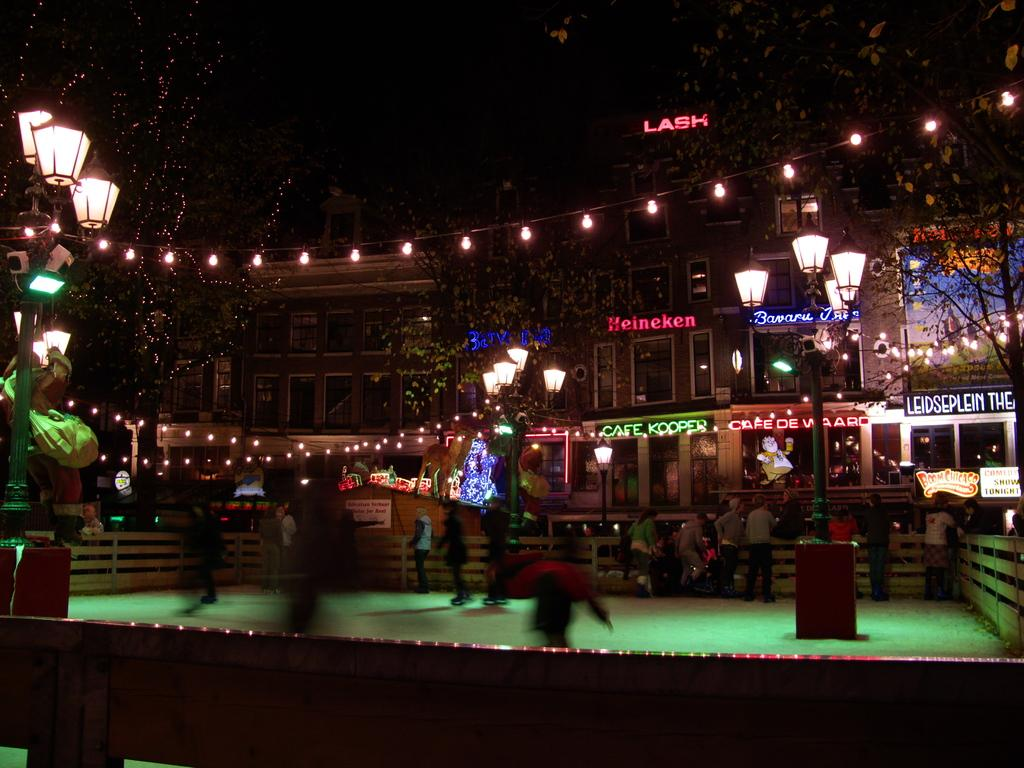What can be seen on the path in the image? There are people on the path in the image. What is present from left to right in the image? There is fencing from left to right in the image. What can be seen in the background of the image? There are lights and buildings visible in the background of the image. What type of thought can be seen in the image? There is no thought visible in the image, as thoughts are not something that can be seen. What type of engine is powering the squirrel in the image? There is no squirrel present in the image, and therefore no engine is powering it. 